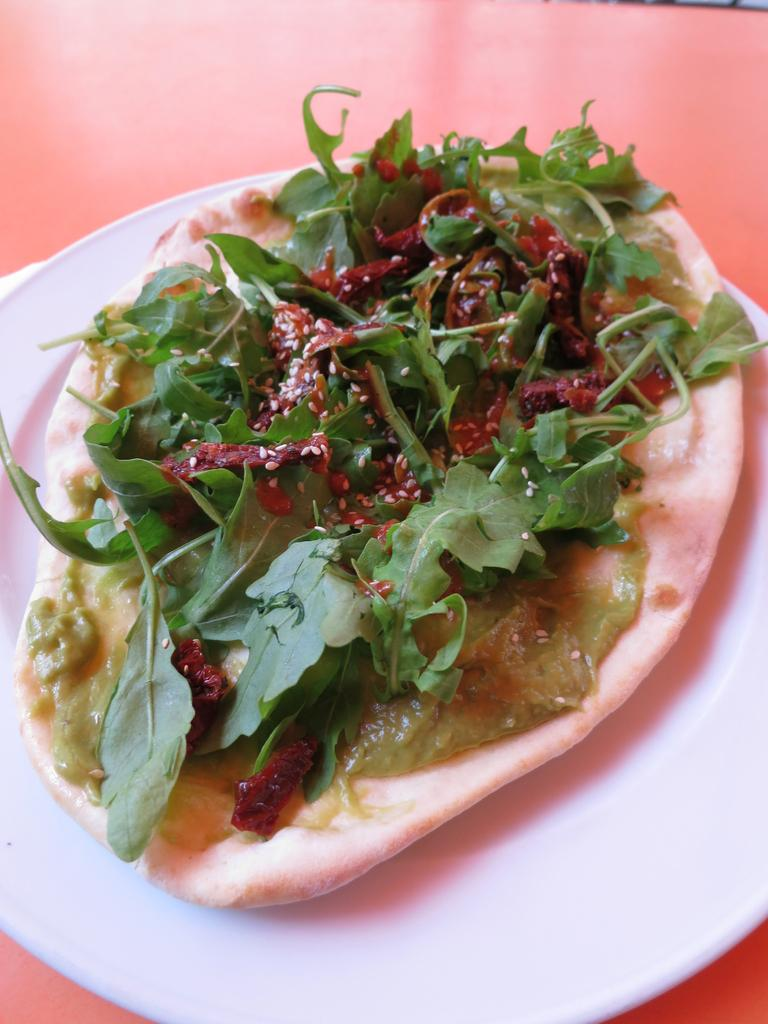What color is the plate in the image? The plate in the image is white. What is on the plate? There is cream on the plate. What is on top of the cream? There are leafy vegetables on the cream. Can you see any fangs on the leafy vegetables in the image? There are no fangs present on the leafy vegetables in the image. 